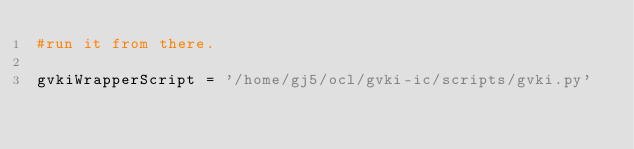<code> <loc_0><loc_0><loc_500><loc_500><_Python_>#run it from there.

gvkiWrapperScript = '/home/gj5/ocl/gvki-ic/scripts/gvki.py'</code> 